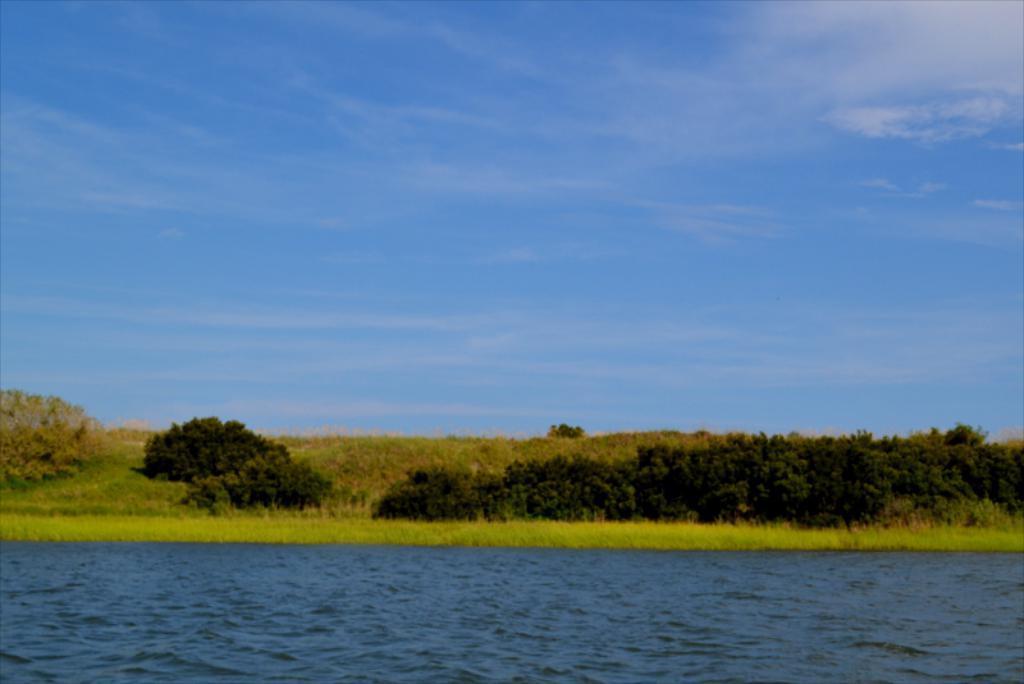How would you summarize this image in a sentence or two? In this image, I can see the water. It looks like the grass. These are the trees. At the top of the image, I can see the sky with the clouds. 